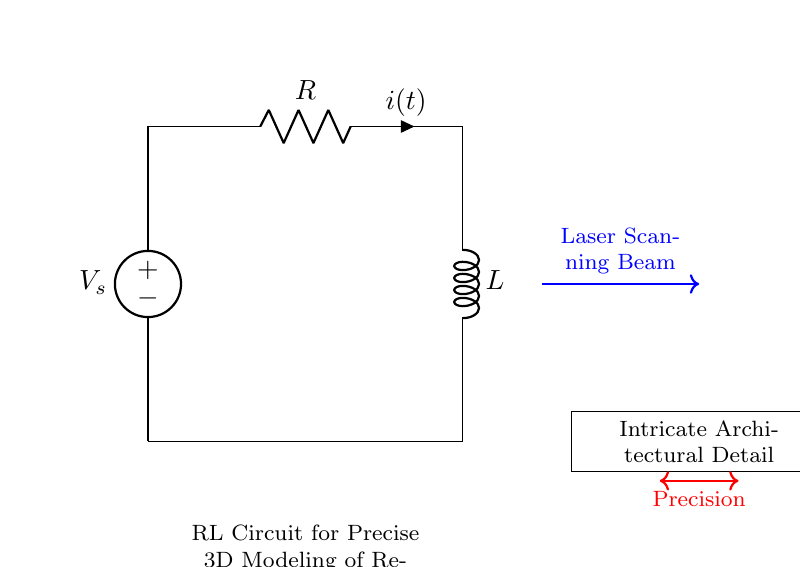What is the voltage source labeled in this circuit? The voltage source is labeled as \( V_s \), which represents the voltage supplied to the circuit.
Answer: V_s What are the two main components of this RL circuit? The components of the circuit are a resistor and an inductor, indicated by the labels R and L respectively.
Answer: Resistor and Inductor What is the current direction indicated by the arrow in the circuit? The current direction, indicated by the arrow and labeled \( i(t) \), shows that it flows from the resistor towards the inductor in a clockwise direction.
Answer: Clockwise What does the blue arrow represent in this circuit? The blue arrow signifies the laser scanning beam, which is essential for capturing the details of the architectural features during scanning.
Answer: Laser Scanning Beam How does the RL circuit contribute to precision in 3D modeling of Renaissance architecture? The RL circuit's ability to filter signals helps in refining the data captured by the laser scanning beam, thereby enhancing the precision in capturing intricate details.
Answer: Enhances precision What does the red double-headed arrow connecting to the "Intricate Architectural Detail" signify? The red double-headed arrow illustrates the relationship between the circuit's output and the precision achieved in 3D modeling, emphasizing the circuit's role in accurately modeling architectural details.
Answer: Precision What will happen if the resistance in the circuit is increased? Increasing the resistance will reduce the current flow through the circuit, which may affect the response time and accuracy of the laser scanning process.
Answer: Reduced current flow 